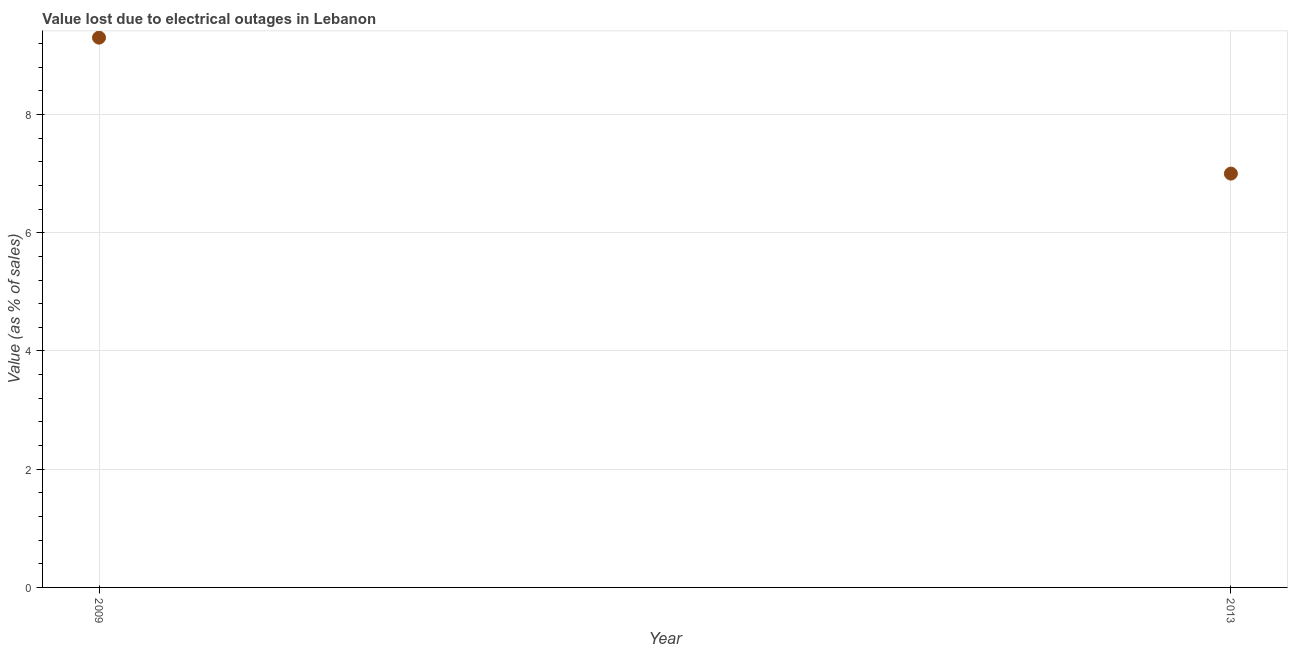Across all years, what is the maximum value lost due to electrical outages?
Make the answer very short. 9.3. Across all years, what is the minimum value lost due to electrical outages?
Keep it short and to the point. 7. In which year was the value lost due to electrical outages maximum?
Provide a succinct answer. 2009. In which year was the value lost due to electrical outages minimum?
Provide a short and direct response. 2013. What is the sum of the value lost due to electrical outages?
Your response must be concise. 16.3. What is the difference between the value lost due to electrical outages in 2009 and 2013?
Provide a short and direct response. 2.3. What is the average value lost due to electrical outages per year?
Offer a very short reply. 8.15. What is the median value lost due to electrical outages?
Give a very brief answer. 8.15. What is the ratio of the value lost due to electrical outages in 2009 to that in 2013?
Give a very brief answer. 1.33. Are the values on the major ticks of Y-axis written in scientific E-notation?
Give a very brief answer. No. Does the graph contain any zero values?
Your answer should be compact. No. Does the graph contain grids?
Provide a short and direct response. Yes. What is the title of the graph?
Your answer should be compact. Value lost due to electrical outages in Lebanon. What is the label or title of the Y-axis?
Keep it short and to the point. Value (as % of sales). What is the Value (as % of sales) in 2013?
Give a very brief answer. 7. What is the difference between the Value (as % of sales) in 2009 and 2013?
Provide a short and direct response. 2.3. What is the ratio of the Value (as % of sales) in 2009 to that in 2013?
Give a very brief answer. 1.33. 